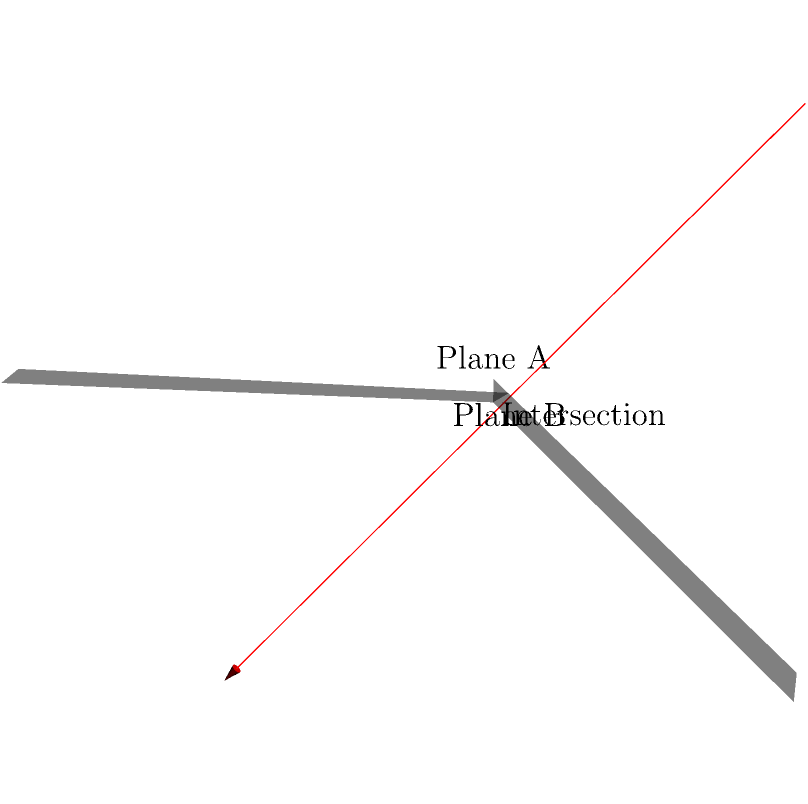In a 3D coordinate system, two planes are given:

Plane A: $x + 2y - z = 2$
Plane B: $2x - y + z = 1$

As a systems software engineer working on network communication and API design, you need to optimize data transfer by determining the most efficient way to represent the intersection of these planes. What is the parametric equation of the line of intersection between these two planes? To find the parametric equation of the line of intersection, we'll follow these steps:

1) First, we need to find the direction vector of the line. This is given by the cross product of the normal vectors of the two planes:

   Plane A normal vector: $\vec{n_1} = (1, 2, -1)$
   Plane B normal vector: $\vec{n_2} = (2, -1, 1)$

   Direction vector $\vec{d} = \vec{n_1} \times \vec{n_2}$
   $$ \vec{d} = (2(1) - (-1)(2), (-1)(1) - (2)(-1), (1)(-1) - (2)(2)) = (4, 1, -5) $$

2) Next, we need to find a point on the line. We can do this by solving the system of equations:

   $x + 2y - z = 2$
   $2x - y + z = 1$

3) Let's eliminate z by adding the equations:

   $3x + y = 3$

4) Now substitute this into one of the original equations, say the first one:

   $x + 2y - z = 2$
   $x + 2(\frac{3-3x}{1}) - z = 2$
   $x + 6 - 6x - z = 2$
   $-5x - z = -4$
   $z = 4 - 5x$

5) Substitute this back into $3x + y = 3$:

   $y = 3 - 3x$

6) Now we have a point on the line: $(0, 3, 4)$

7) The parametric equation of the line is:

   $x = 0 + 4t$
   $y = 3 + t$
   $z = 4 - 5t$

   Or in vector form: $\vec{r} = (0, 3, 4) + t(4, 1, -5)$

This representation allows for efficient data transfer as it encapsulates the entire line in a compact form, which is crucial for optimizing network communication in API design.
Answer: $\vec{r} = (0, 3, 4) + t(4, 1, -5)$ 